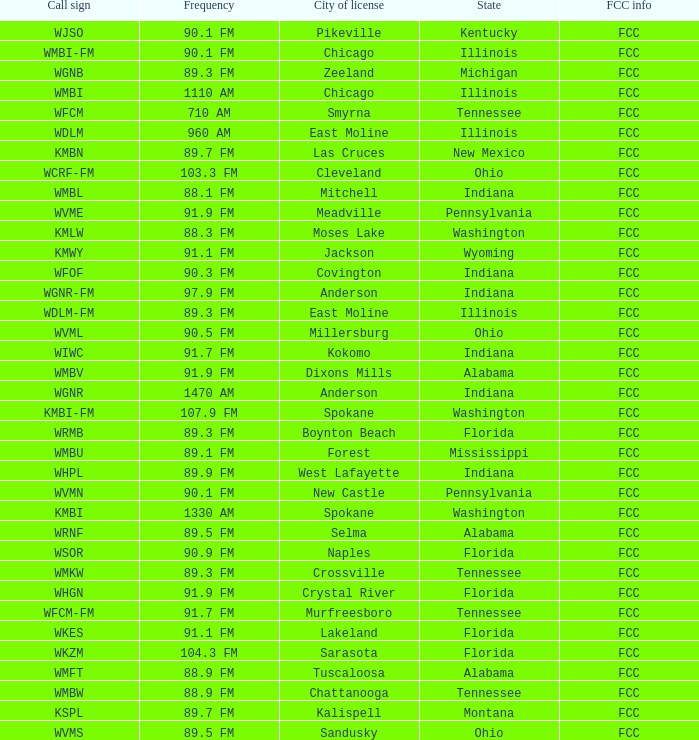What is the FCC info for the radio station in West Lafayette, Indiana? FCC. 